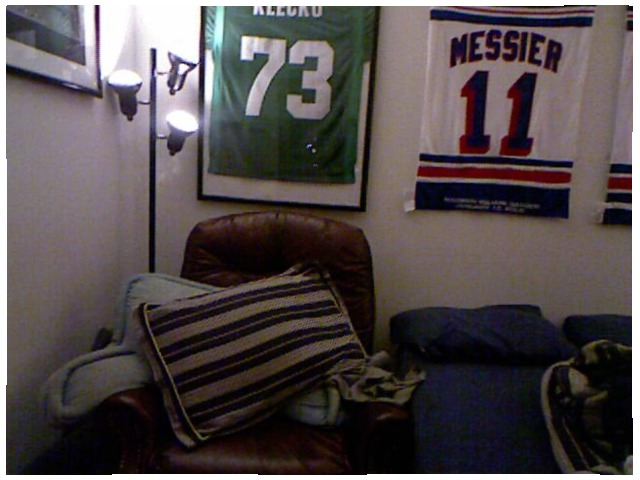<image>
Can you confirm if the cloth is on the wall? Yes. Looking at the image, I can see the cloth is positioned on top of the wall, with the wall providing support. Is the tshirt on the wall? Yes. Looking at the image, I can see the tshirt is positioned on top of the wall, with the wall providing support. Is the shirt on the chair? No. The shirt is not positioned on the chair. They may be near each other, but the shirt is not supported by or resting on top of the chair. Is there a chair next to the pillow? No. The chair is not positioned next to the pillow. They are located in different areas of the scene. Where is the jersey in relation to the glass? Is it behind the glass? Yes. From this viewpoint, the jersey is positioned behind the glass, with the glass partially or fully occluding the jersey. Is the cushion behind the cushion? Yes. From this viewpoint, the cushion is positioned behind the cushion, with the cushion partially or fully occluding the cushion. Is there a pillow to the left of the blanket? Yes. From this viewpoint, the pillow is positioned to the left side relative to the blanket. 